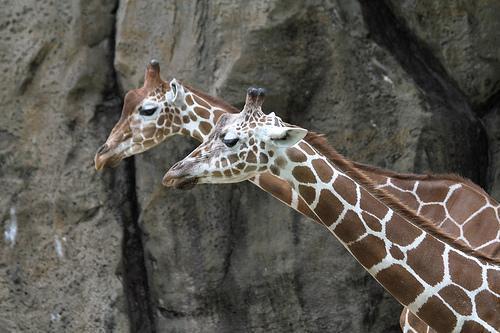How many giraffes are shown?
Give a very brief answer. 2. 